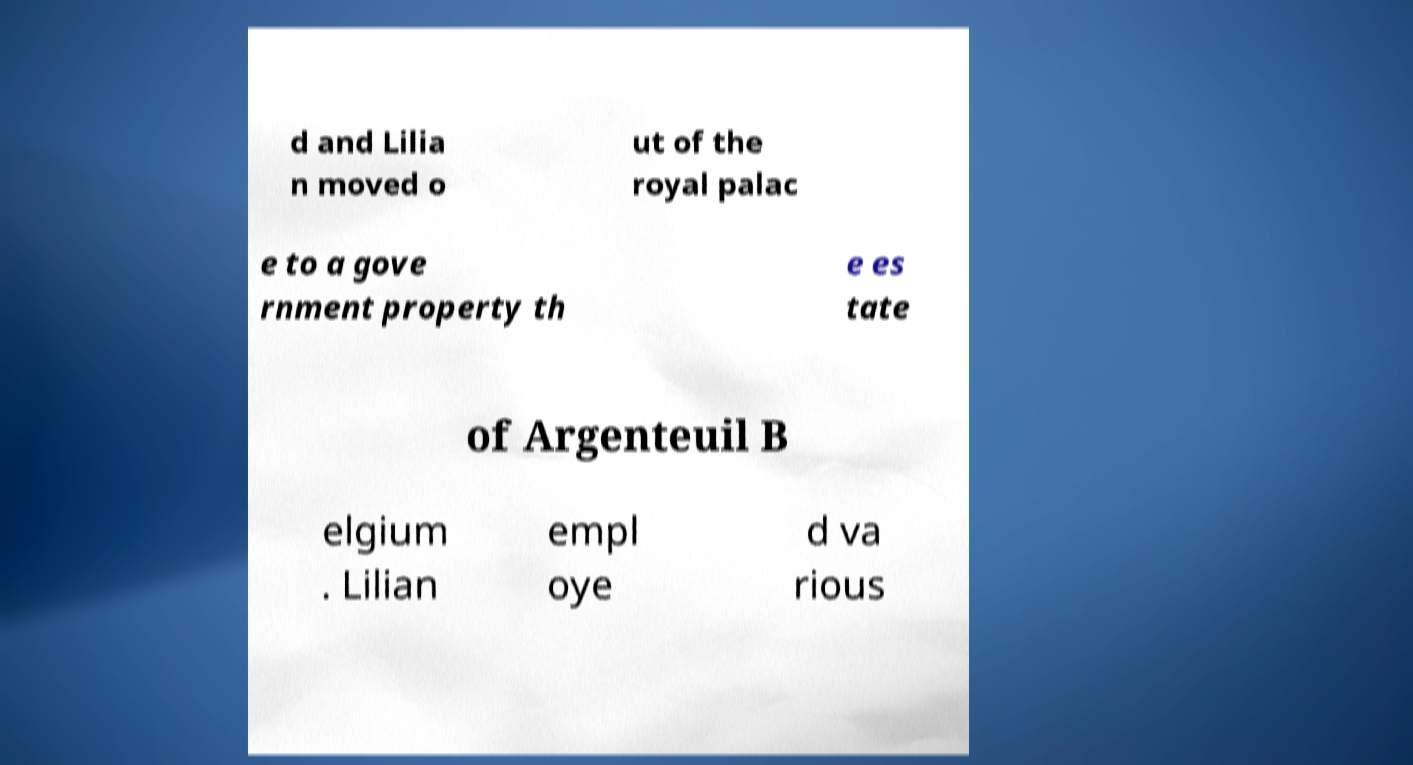Could you extract and type out the text from this image? d and Lilia n moved o ut of the royal palac e to a gove rnment property th e es tate of Argenteuil B elgium . Lilian empl oye d va rious 